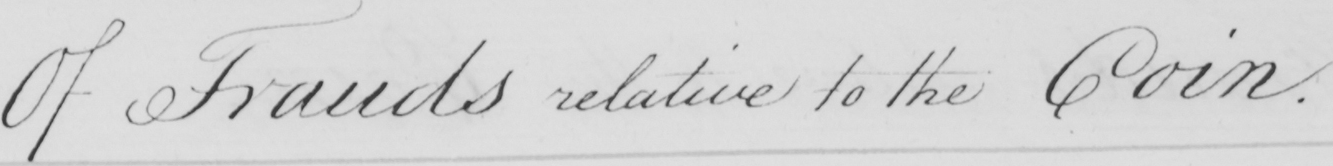What text is written in this handwritten line? Of Frauds relative to the Coin . 